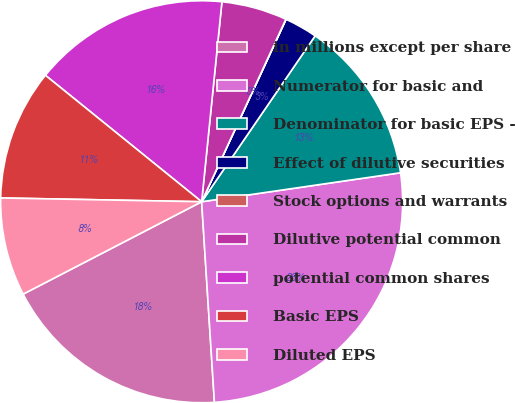<chart> <loc_0><loc_0><loc_500><loc_500><pie_chart><fcel>in millions except per share<fcel>Numerator for basic and<fcel>Denominator for basic EPS -<fcel>Effect of dilutive securities<fcel>Stock options and warrants<fcel>Dilutive potential common<fcel>potential common shares<fcel>Basic EPS<fcel>Diluted EPS<nl><fcel>18.41%<fcel>26.29%<fcel>13.15%<fcel>2.65%<fcel>0.02%<fcel>5.27%<fcel>15.78%<fcel>10.53%<fcel>7.9%<nl></chart> 